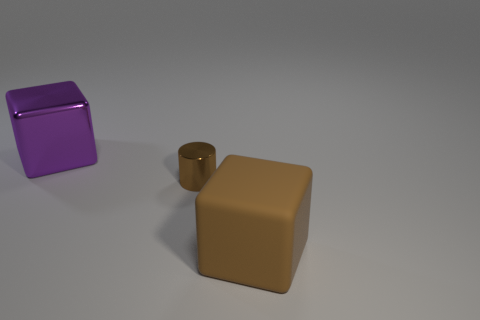Subtract all purple cubes. How many cubes are left? 1 Subtract 1 cylinders. How many cylinders are left? 0 Add 2 large purple blocks. How many objects exist? 5 Subtract 1 brown cylinders. How many objects are left? 2 Subtract all cylinders. How many objects are left? 2 Subtract all cyan cylinders. Subtract all purple blocks. How many cylinders are left? 1 Subtract all green spheres. How many purple cubes are left? 1 Subtract all large blue cubes. Subtract all big objects. How many objects are left? 1 Add 3 large purple shiny cubes. How many large purple shiny cubes are left? 4 Add 2 big shiny things. How many big shiny things exist? 3 